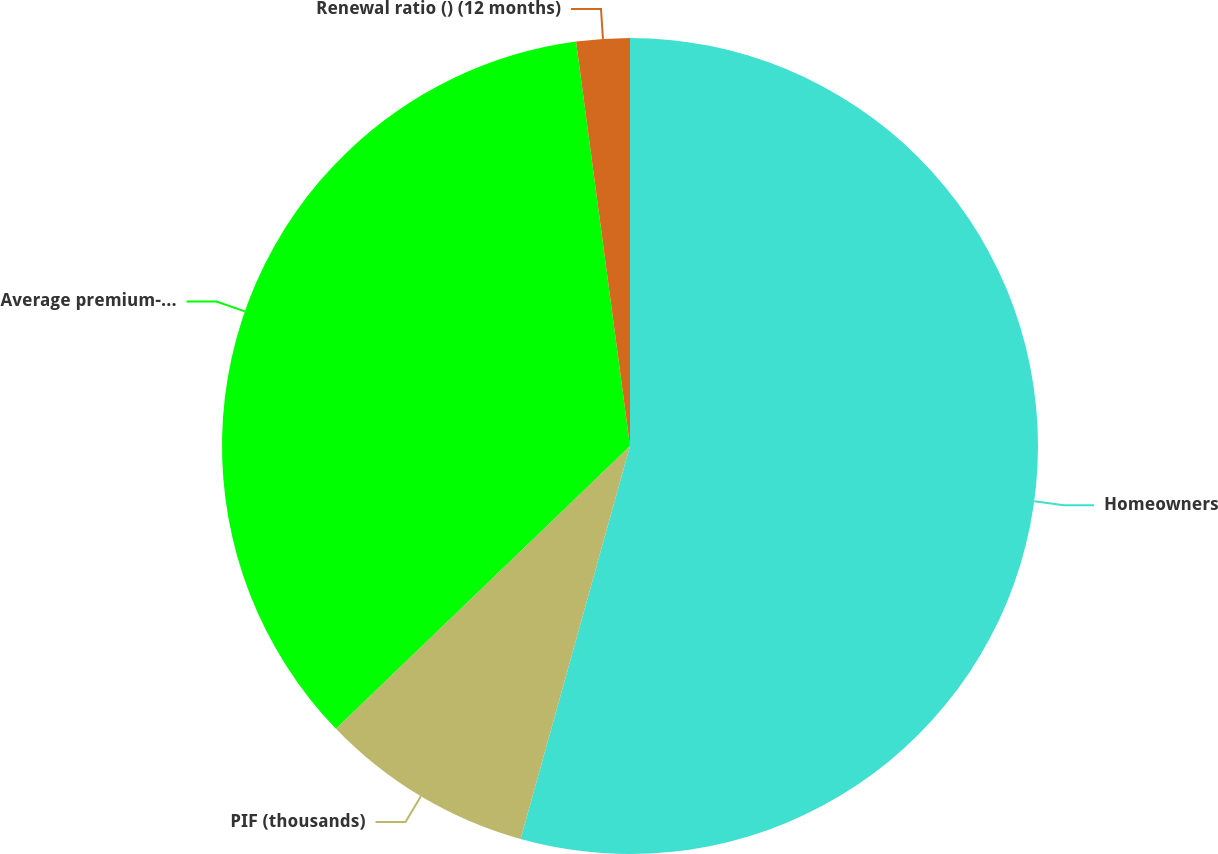Convert chart. <chart><loc_0><loc_0><loc_500><loc_500><pie_chart><fcel>Homeowners<fcel>PIF (thousands)<fcel>Average premium-gross written<fcel>Renewal ratio () (12 months)<nl><fcel>54.32%<fcel>8.49%<fcel>35.08%<fcel>2.11%<nl></chart> 